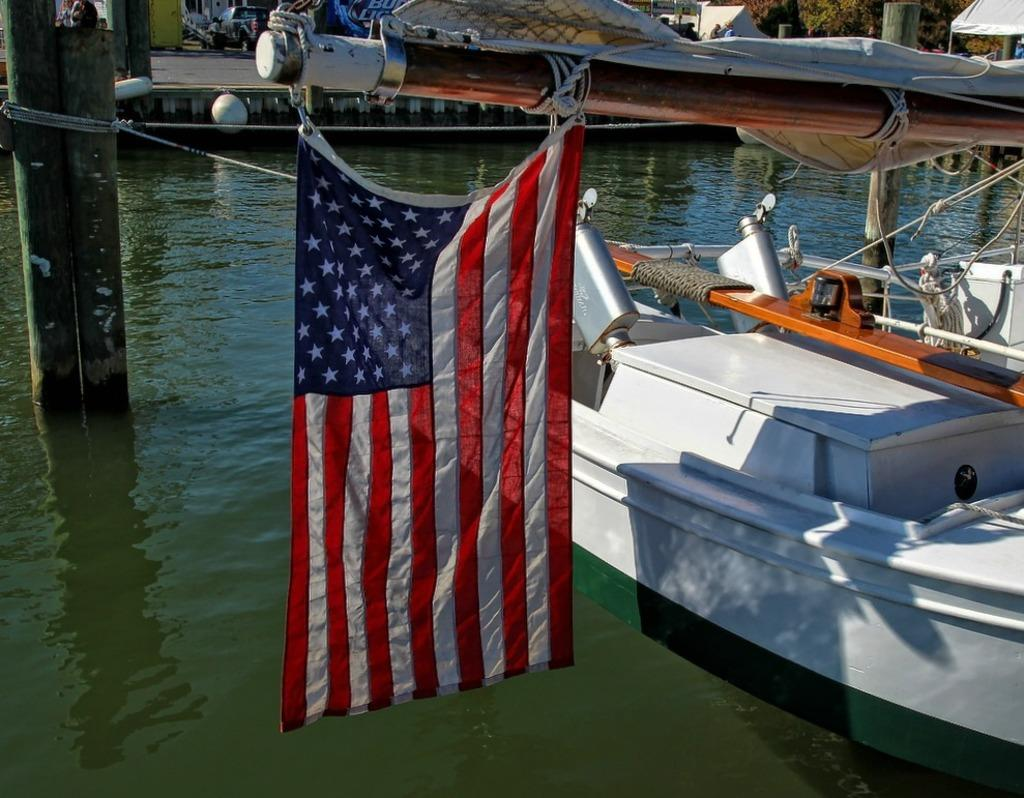What is hanging on a pole in the image? There is a flag in the image that is hanged on a pole. What is floating on the water in the image? There is a white boat in the image that is floating on the water. What type of structure can be seen in the image? There are pillars in the image, which might be part of a larger structure. What can be seen in the background of the image? There is a vehicle and trees present in the background of the image. What type of blade is being used to recite a verse in the image? There is no blade or verse present in the image; it features a flag, a boat, pillars, a vehicle, and trees. What time of day is depicted in the image? The time of day cannot be determined from the image, as there are no specific clues or indicators present. 